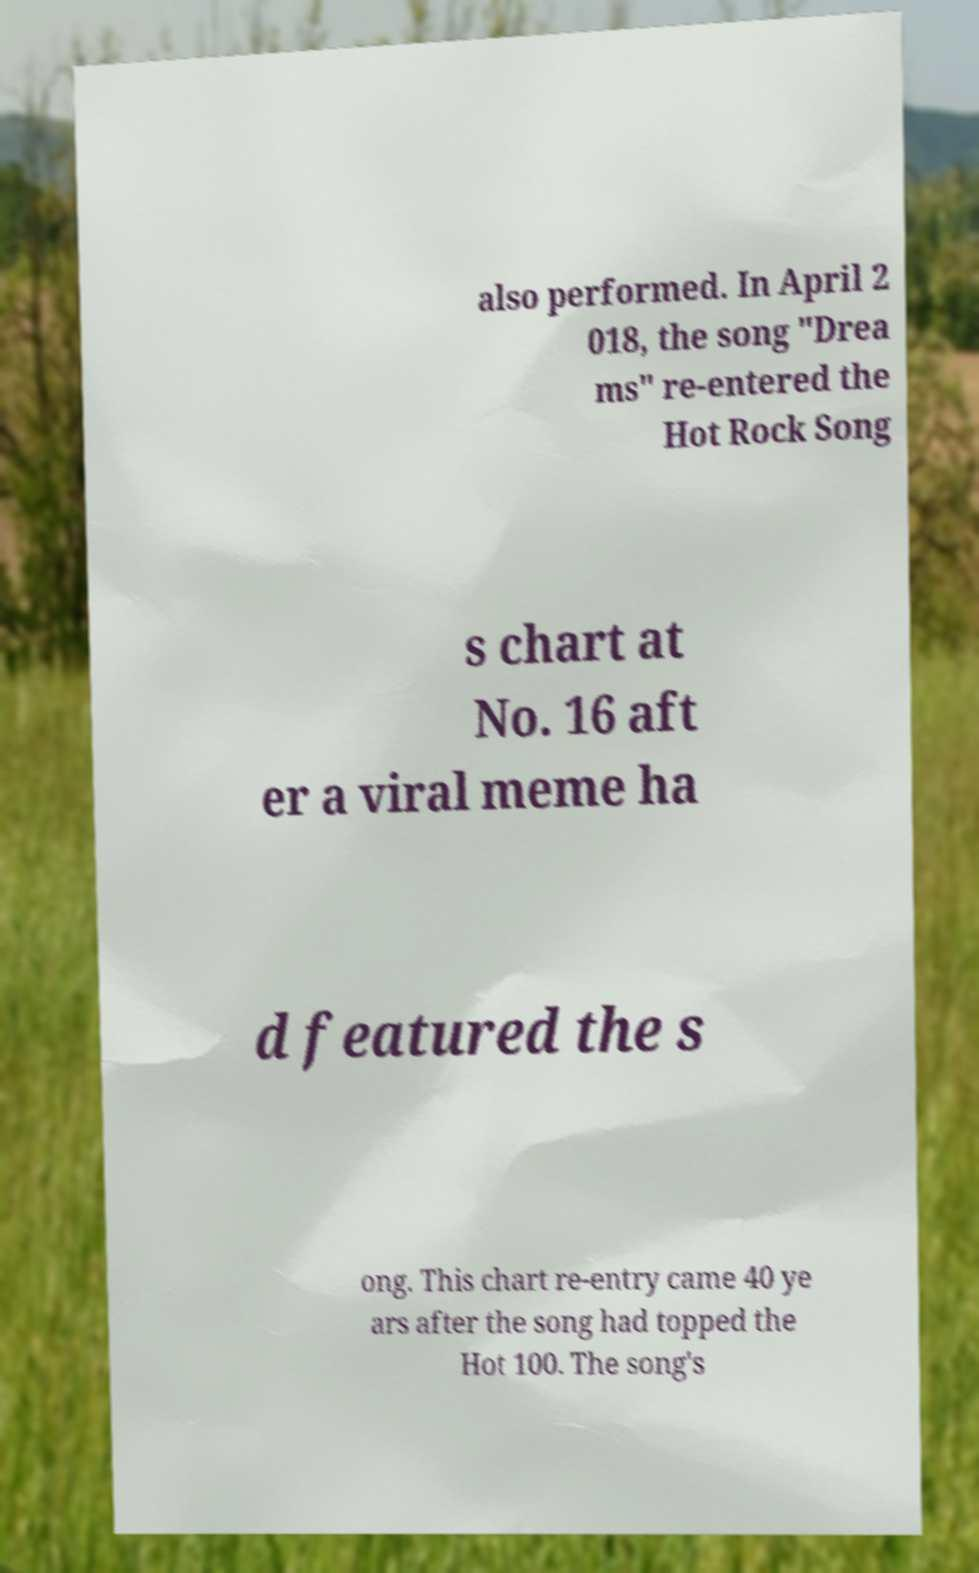I need the written content from this picture converted into text. Can you do that? also performed. In April 2 018, the song "Drea ms" re-entered the Hot Rock Song s chart at No. 16 aft er a viral meme ha d featured the s ong. This chart re-entry came 40 ye ars after the song had topped the Hot 100. The song's 